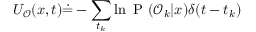Convert formula to latex. <formula><loc_0><loc_0><loc_500><loc_500>{ U _ { \mathcal { O } } ( x , t ) \dot { = } - \sum _ { t _ { k } } \ln P ( \mathcal { O } _ { k } | x ) \delta ( t - t _ { k } ) }</formula> 